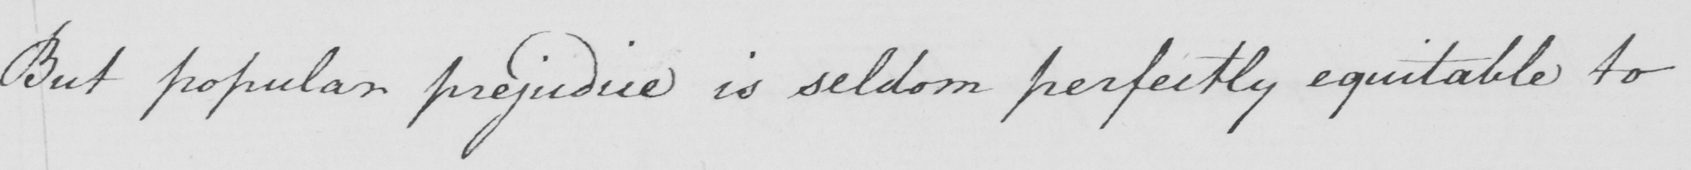Please provide the text content of this handwritten line. But popular prejudice is seldom perfectly equitable to 